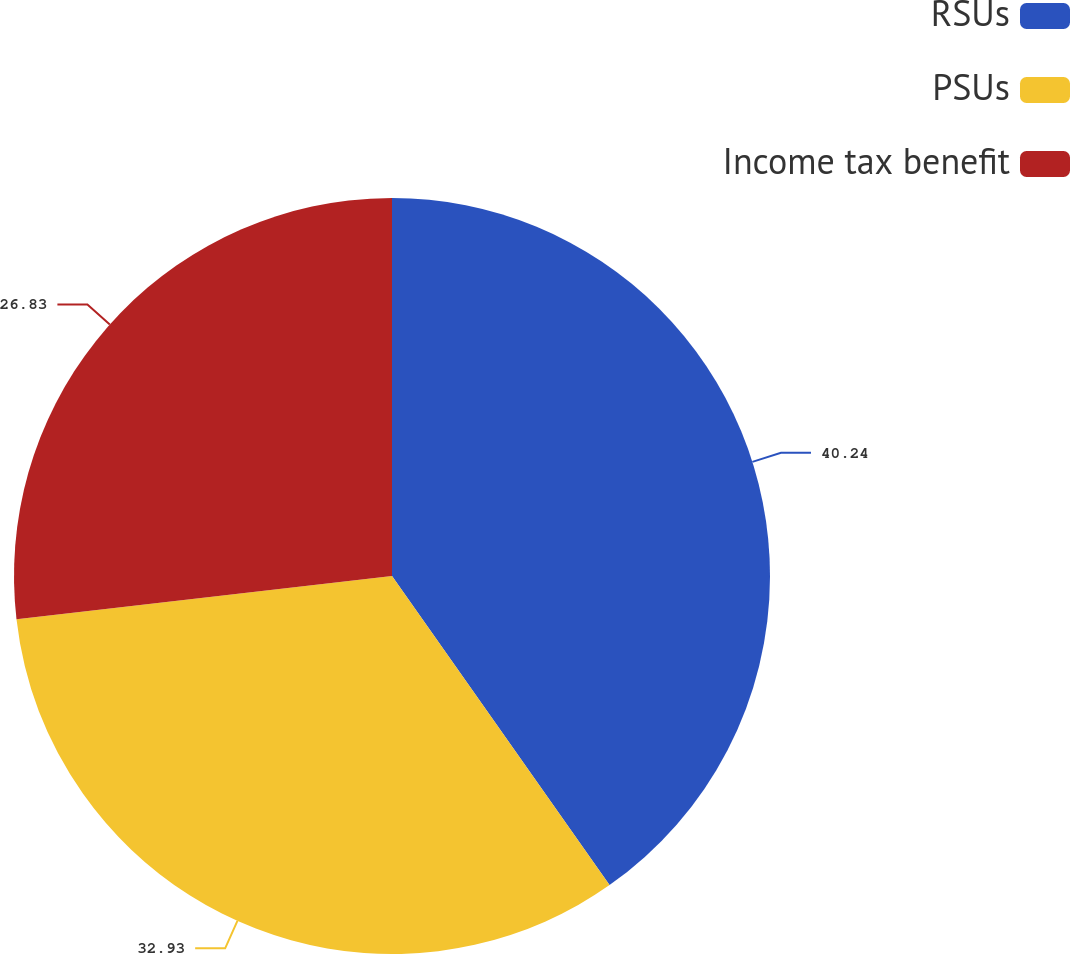Convert chart. <chart><loc_0><loc_0><loc_500><loc_500><pie_chart><fcel>RSUs<fcel>PSUs<fcel>Income tax benefit<nl><fcel>40.24%<fcel>32.93%<fcel>26.83%<nl></chart> 